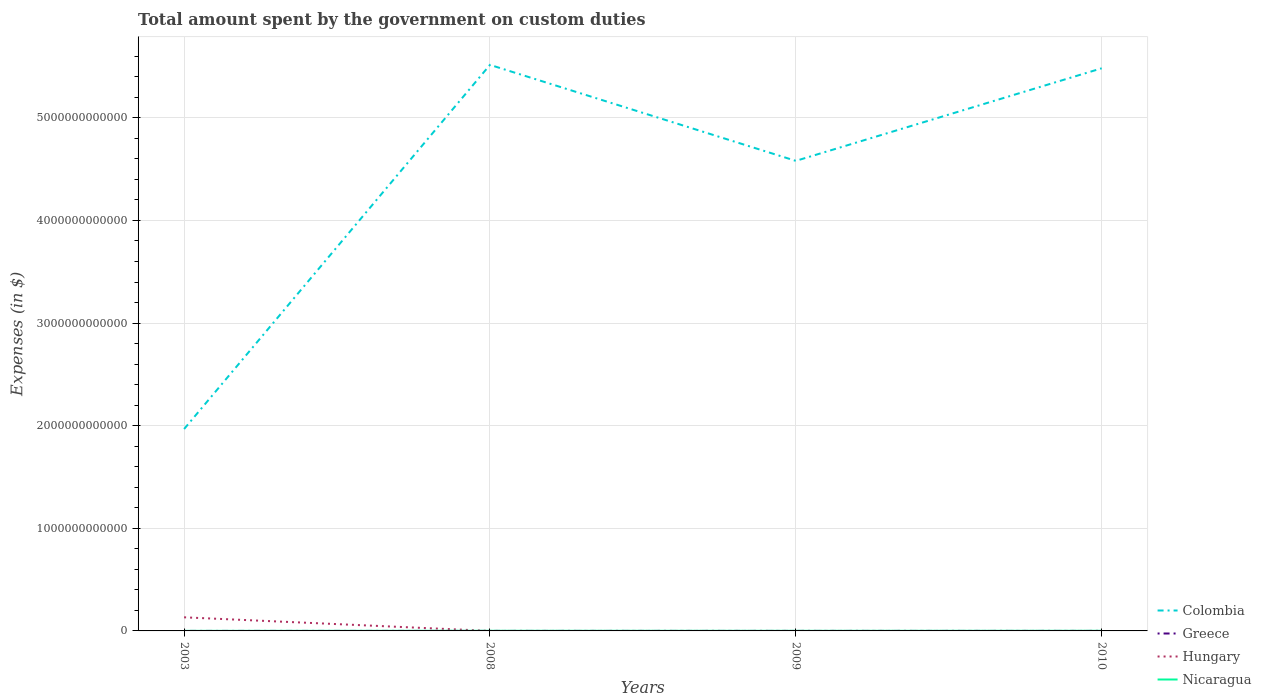Does the line corresponding to Hungary intersect with the line corresponding to Greece?
Provide a succinct answer. Yes. Across all years, what is the maximum amount spent on custom duties by the government in Nicaragua?
Offer a very short reply. 6.28e+08. What is the difference between the highest and the second highest amount spent on custom duties by the government in Greece?
Your response must be concise. 1.40e+07. How many years are there in the graph?
Your response must be concise. 4. What is the difference between two consecutive major ticks on the Y-axis?
Give a very brief answer. 1.00e+12. Does the graph contain grids?
Ensure brevity in your answer.  Yes. How many legend labels are there?
Your answer should be compact. 4. What is the title of the graph?
Provide a succinct answer. Total amount spent by the government on custom duties. Does "Guinea-Bissau" appear as one of the legend labels in the graph?
Provide a succinct answer. No. What is the label or title of the Y-axis?
Make the answer very short. Expenses (in $). What is the Expenses (in $) of Colombia in 2003?
Offer a very short reply. 1.97e+12. What is the Expenses (in $) of Greece in 2003?
Offer a very short reply. 1.50e+07. What is the Expenses (in $) in Hungary in 2003?
Your response must be concise. 1.33e+11. What is the Expenses (in $) in Nicaragua in 2003?
Ensure brevity in your answer.  6.28e+08. What is the Expenses (in $) of Colombia in 2008?
Your answer should be compact. 5.52e+12. What is the Expenses (in $) of Hungary in 2008?
Ensure brevity in your answer.  0. What is the Expenses (in $) of Nicaragua in 2008?
Your answer should be compact. 1.18e+09. What is the Expenses (in $) in Colombia in 2009?
Make the answer very short. 4.58e+12. What is the Expenses (in $) in Nicaragua in 2009?
Keep it short and to the point. 9.70e+08. What is the Expenses (in $) of Colombia in 2010?
Offer a terse response. 5.48e+12. What is the Expenses (in $) of Greece in 2010?
Make the answer very short. 1.00e+06. What is the Expenses (in $) in Nicaragua in 2010?
Your answer should be very brief. 1.19e+09. Across all years, what is the maximum Expenses (in $) of Colombia?
Ensure brevity in your answer.  5.52e+12. Across all years, what is the maximum Expenses (in $) in Greece?
Your response must be concise. 1.50e+07. Across all years, what is the maximum Expenses (in $) of Hungary?
Your answer should be very brief. 1.33e+11. Across all years, what is the maximum Expenses (in $) of Nicaragua?
Give a very brief answer. 1.19e+09. Across all years, what is the minimum Expenses (in $) in Colombia?
Your response must be concise. 1.97e+12. Across all years, what is the minimum Expenses (in $) of Nicaragua?
Your answer should be very brief. 6.28e+08. What is the total Expenses (in $) of Colombia in the graph?
Ensure brevity in your answer.  1.75e+13. What is the total Expenses (in $) of Greece in the graph?
Offer a very short reply. 1.90e+07. What is the total Expenses (in $) in Hungary in the graph?
Give a very brief answer. 1.33e+11. What is the total Expenses (in $) of Nicaragua in the graph?
Keep it short and to the point. 3.97e+09. What is the difference between the Expenses (in $) in Colombia in 2003 and that in 2008?
Offer a terse response. -3.55e+12. What is the difference between the Expenses (in $) in Greece in 2003 and that in 2008?
Keep it short and to the point. 1.30e+07. What is the difference between the Expenses (in $) of Nicaragua in 2003 and that in 2008?
Your response must be concise. -5.55e+08. What is the difference between the Expenses (in $) of Colombia in 2003 and that in 2009?
Provide a short and direct response. -2.61e+12. What is the difference between the Expenses (in $) of Greece in 2003 and that in 2009?
Provide a short and direct response. 1.40e+07. What is the difference between the Expenses (in $) in Nicaragua in 2003 and that in 2009?
Your answer should be very brief. -3.42e+08. What is the difference between the Expenses (in $) of Colombia in 2003 and that in 2010?
Provide a succinct answer. -3.52e+12. What is the difference between the Expenses (in $) of Greece in 2003 and that in 2010?
Provide a short and direct response. 1.40e+07. What is the difference between the Expenses (in $) in Nicaragua in 2003 and that in 2010?
Offer a very short reply. -5.63e+08. What is the difference between the Expenses (in $) of Colombia in 2008 and that in 2009?
Your answer should be compact. 9.35e+11. What is the difference between the Expenses (in $) of Greece in 2008 and that in 2009?
Offer a terse response. 1.00e+06. What is the difference between the Expenses (in $) in Nicaragua in 2008 and that in 2009?
Your answer should be compact. 2.13e+08. What is the difference between the Expenses (in $) of Colombia in 2008 and that in 2010?
Your answer should be compact. 3.33e+1. What is the difference between the Expenses (in $) in Greece in 2008 and that in 2010?
Your response must be concise. 1.00e+06. What is the difference between the Expenses (in $) in Nicaragua in 2008 and that in 2010?
Provide a succinct answer. -7.60e+06. What is the difference between the Expenses (in $) in Colombia in 2009 and that in 2010?
Your response must be concise. -9.02e+11. What is the difference between the Expenses (in $) of Nicaragua in 2009 and that in 2010?
Provide a succinct answer. -2.21e+08. What is the difference between the Expenses (in $) of Colombia in 2003 and the Expenses (in $) of Greece in 2008?
Give a very brief answer. 1.97e+12. What is the difference between the Expenses (in $) in Colombia in 2003 and the Expenses (in $) in Nicaragua in 2008?
Keep it short and to the point. 1.97e+12. What is the difference between the Expenses (in $) in Greece in 2003 and the Expenses (in $) in Nicaragua in 2008?
Provide a short and direct response. -1.17e+09. What is the difference between the Expenses (in $) of Hungary in 2003 and the Expenses (in $) of Nicaragua in 2008?
Offer a very short reply. 1.31e+11. What is the difference between the Expenses (in $) in Colombia in 2003 and the Expenses (in $) in Greece in 2009?
Offer a very short reply. 1.97e+12. What is the difference between the Expenses (in $) in Colombia in 2003 and the Expenses (in $) in Nicaragua in 2009?
Offer a terse response. 1.97e+12. What is the difference between the Expenses (in $) of Greece in 2003 and the Expenses (in $) of Nicaragua in 2009?
Give a very brief answer. -9.55e+08. What is the difference between the Expenses (in $) of Hungary in 2003 and the Expenses (in $) of Nicaragua in 2009?
Make the answer very short. 1.32e+11. What is the difference between the Expenses (in $) of Colombia in 2003 and the Expenses (in $) of Greece in 2010?
Your answer should be very brief. 1.97e+12. What is the difference between the Expenses (in $) of Colombia in 2003 and the Expenses (in $) of Nicaragua in 2010?
Make the answer very short. 1.97e+12. What is the difference between the Expenses (in $) in Greece in 2003 and the Expenses (in $) in Nicaragua in 2010?
Ensure brevity in your answer.  -1.18e+09. What is the difference between the Expenses (in $) in Hungary in 2003 and the Expenses (in $) in Nicaragua in 2010?
Your answer should be very brief. 1.31e+11. What is the difference between the Expenses (in $) of Colombia in 2008 and the Expenses (in $) of Greece in 2009?
Give a very brief answer. 5.52e+12. What is the difference between the Expenses (in $) of Colombia in 2008 and the Expenses (in $) of Nicaragua in 2009?
Give a very brief answer. 5.51e+12. What is the difference between the Expenses (in $) in Greece in 2008 and the Expenses (in $) in Nicaragua in 2009?
Ensure brevity in your answer.  -9.68e+08. What is the difference between the Expenses (in $) of Colombia in 2008 and the Expenses (in $) of Greece in 2010?
Your answer should be compact. 5.52e+12. What is the difference between the Expenses (in $) of Colombia in 2008 and the Expenses (in $) of Nicaragua in 2010?
Ensure brevity in your answer.  5.51e+12. What is the difference between the Expenses (in $) of Greece in 2008 and the Expenses (in $) of Nicaragua in 2010?
Make the answer very short. -1.19e+09. What is the difference between the Expenses (in $) of Colombia in 2009 and the Expenses (in $) of Greece in 2010?
Give a very brief answer. 4.58e+12. What is the difference between the Expenses (in $) in Colombia in 2009 and the Expenses (in $) in Nicaragua in 2010?
Offer a very short reply. 4.58e+12. What is the difference between the Expenses (in $) of Greece in 2009 and the Expenses (in $) of Nicaragua in 2010?
Make the answer very short. -1.19e+09. What is the average Expenses (in $) of Colombia per year?
Keep it short and to the point. 4.39e+12. What is the average Expenses (in $) of Greece per year?
Ensure brevity in your answer.  4.75e+06. What is the average Expenses (in $) in Hungary per year?
Your answer should be compact. 3.32e+1. What is the average Expenses (in $) in Nicaragua per year?
Ensure brevity in your answer.  9.93e+08. In the year 2003, what is the difference between the Expenses (in $) of Colombia and Expenses (in $) of Greece?
Provide a short and direct response. 1.97e+12. In the year 2003, what is the difference between the Expenses (in $) of Colombia and Expenses (in $) of Hungary?
Keep it short and to the point. 1.83e+12. In the year 2003, what is the difference between the Expenses (in $) in Colombia and Expenses (in $) in Nicaragua?
Your answer should be compact. 1.97e+12. In the year 2003, what is the difference between the Expenses (in $) of Greece and Expenses (in $) of Hungary?
Provide a short and direct response. -1.33e+11. In the year 2003, what is the difference between the Expenses (in $) in Greece and Expenses (in $) in Nicaragua?
Your answer should be very brief. -6.13e+08. In the year 2003, what is the difference between the Expenses (in $) in Hungary and Expenses (in $) in Nicaragua?
Provide a succinct answer. 1.32e+11. In the year 2008, what is the difference between the Expenses (in $) of Colombia and Expenses (in $) of Greece?
Offer a very short reply. 5.52e+12. In the year 2008, what is the difference between the Expenses (in $) in Colombia and Expenses (in $) in Nicaragua?
Your answer should be compact. 5.51e+12. In the year 2008, what is the difference between the Expenses (in $) of Greece and Expenses (in $) of Nicaragua?
Provide a short and direct response. -1.18e+09. In the year 2009, what is the difference between the Expenses (in $) of Colombia and Expenses (in $) of Greece?
Provide a succinct answer. 4.58e+12. In the year 2009, what is the difference between the Expenses (in $) of Colombia and Expenses (in $) of Nicaragua?
Provide a short and direct response. 4.58e+12. In the year 2009, what is the difference between the Expenses (in $) in Greece and Expenses (in $) in Nicaragua?
Make the answer very short. -9.69e+08. In the year 2010, what is the difference between the Expenses (in $) in Colombia and Expenses (in $) in Greece?
Ensure brevity in your answer.  5.48e+12. In the year 2010, what is the difference between the Expenses (in $) of Colombia and Expenses (in $) of Nicaragua?
Provide a succinct answer. 5.48e+12. In the year 2010, what is the difference between the Expenses (in $) in Greece and Expenses (in $) in Nicaragua?
Offer a very short reply. -1.19e+09. What is the ratio of the Expenses (in $) of Colombia in 2003 to that in 2008?
Your answer should be compact. 0.36. What is the ratio of the Expenses (in $) in Nicaragua in 2003 to that in 2008?
Your answer should be very brief. 0.53. What is the ratio of the Expenses (in $) of Colombia in 2003 to that in 2009?
Provide a short and direct response. 0.43. What is the ratio of the Expenses (in $) in Greece in 2003 to that in 2009?
Offer a very short reply. 15. What is the ratio of the Expenses (in $) of Nicaragua in 2003 to that in 2009?
Offer a very short reply. 0.65. What is the ratio of the Expenses (in $) of Colombia in 2003 to that in 2010?
Give a very brief answer. 0.36. What is the ratio of the Expenses (in $) of Greece in 2003 to that in 2010?
Provide a succinct answer. 15. What is the ratio of the Expenses (in $) of Nicaragua in 2003 to that in 2010?
Provide a short and direct response. 0.53. What is the ratio of the Expenses (in $) in Colombia in 2008 to that in 2009?
Offer a terse response. 1.2. What is the ratio of the Expenses (in $) in Greece in 2008 to that in 2009?
Offer a very short reply. 2. What is the ratio of the Expenses (in $) of Nicaragua in 2008 to that in 2009?
Keep it short and to the point. 1.22. What is the ratio of the Expenses (in $) of Greece in 2008 to that in 2010?
Give a very brief answer. 2. What is the ratio of the Expenses (in $) in Nicaragua in 2008 to that in 2010?
Offer a terse response. 0.99. What is the ratio of the Expenses (in $) of Colombia in 2009 to that in 2010?
Ensure brevity in your answer.  0.84. What is the ratio of the Expenses (in $) of Greece in 2009 to that in 2010?
Provide a succinct answer. 1. What is the ratio of the Expenses (in $) of Nicaragua in 2009 to that in 2010?
Keep it short and to the point. 0.81. What is the difference between the highest and the second highest Expenses (in $) of Colombia?
Provide a short and direct response. 3.33e+1. What is the difference between the highest and the second highest Expenses (in $) in Greece?
Provide a short and direct response. 1.30e+07. What is the difference between the highest and the second highest Expenses (in $) of Nicaragua?
Your answer should be compact. 7.60e+06. What is the difference between the highest and the lowest Expenses (in $) in Colombia?
Ensure brevity in your answer.  3.55e+12. What is the difference between the highest and the lowest Expenses (in $) in Greece?
Offer a very short reply. 1.40e+07. What is the difference between the highest and the lowest Expenses (in $) in Hungary?
Offer a terse response. 1.33e+11. What is the difference between the highest and the lowest Expenses (in $) in Nicaragua?
Your answer should be compact. 5.63e+08. 